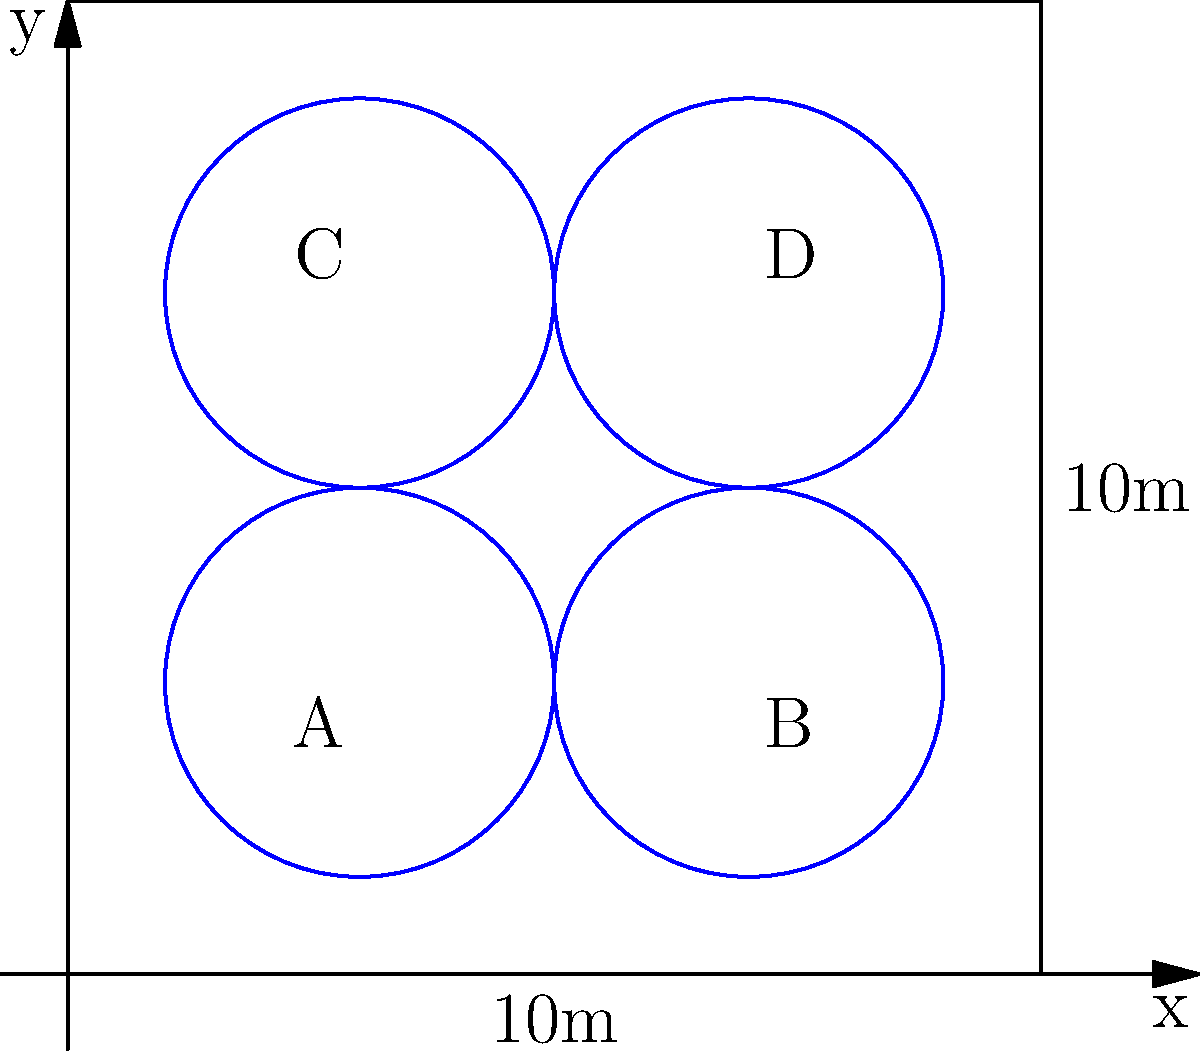In a square vineyard measuring 10m x 10m, four circular sprinklers (A, B, C, and D) are installed as shown in the diagram. Each sprinkler has a coverage radius of 2m. To maximize irrigation efficiency, what percentage of the vineyard's total area is covered by the sprinklers? Round your answer to the nearest whole percent. To solve this problem, we'll follow these steps:

1) Calculate the total area of the vineyard:
   $$A_{vineyard} = 10m \times 10m = 100m^2$$

2) Calculate the area covered by one sprinkler:
   $$A_{sprinkler} = \pi r^2 = \pi (2m)^2 = 4\pi m^2$$

3) Calculate the total area covered by all four sprinklers:
   $$A_{total} = 4 \times 4\pi m^2 = 16\pi m^2$$

4) However, this includes overlapping areas. We need to subtract these:
   - There are 4 areas where two circles overlap
   - Each overlap can be calculated using the formula for the area of intersection of two circles

5) Area of intersection of two circles:
   $$A_{intersection} = 2r^2 \arccos(\frac{d}{2r}) - d\sqrt{r^2 - \frac{d^2}{4}}$$
   where $r = 2m$ (radius) and $d = 4m$ (distance between centers)

6) Calculating:
   $$A_{intersection} = 2(2m)^2 \arccos(\frac{4m}{2(2m)}) - 4m\sqrt{(2m)^2 - \frac{(4m)^2}{4}}$$
   $$= 8m^2 \arccos(0.5) - 4m\sqrt{4m^2 - 4m^2}$$
   $$= 8m^2 (1.0472) - 4m(0) = 8.3776m^2$$

7) Total area covered after subtracting overlaps:
   $$A_{covered} = 16\pi m^2 - 4(8.3776m^2) = 16.5699m^2$$

8) Percentage of vineyard covered:
   $$\frac{A_{covered}}{A_{vineyard}} \times 100\% = \frac{16.5699m^2}{100m^2} \times 100\% = 16.57\%$$

9) Rounding to the nearest whole percent: 17%
Answer: 17% 